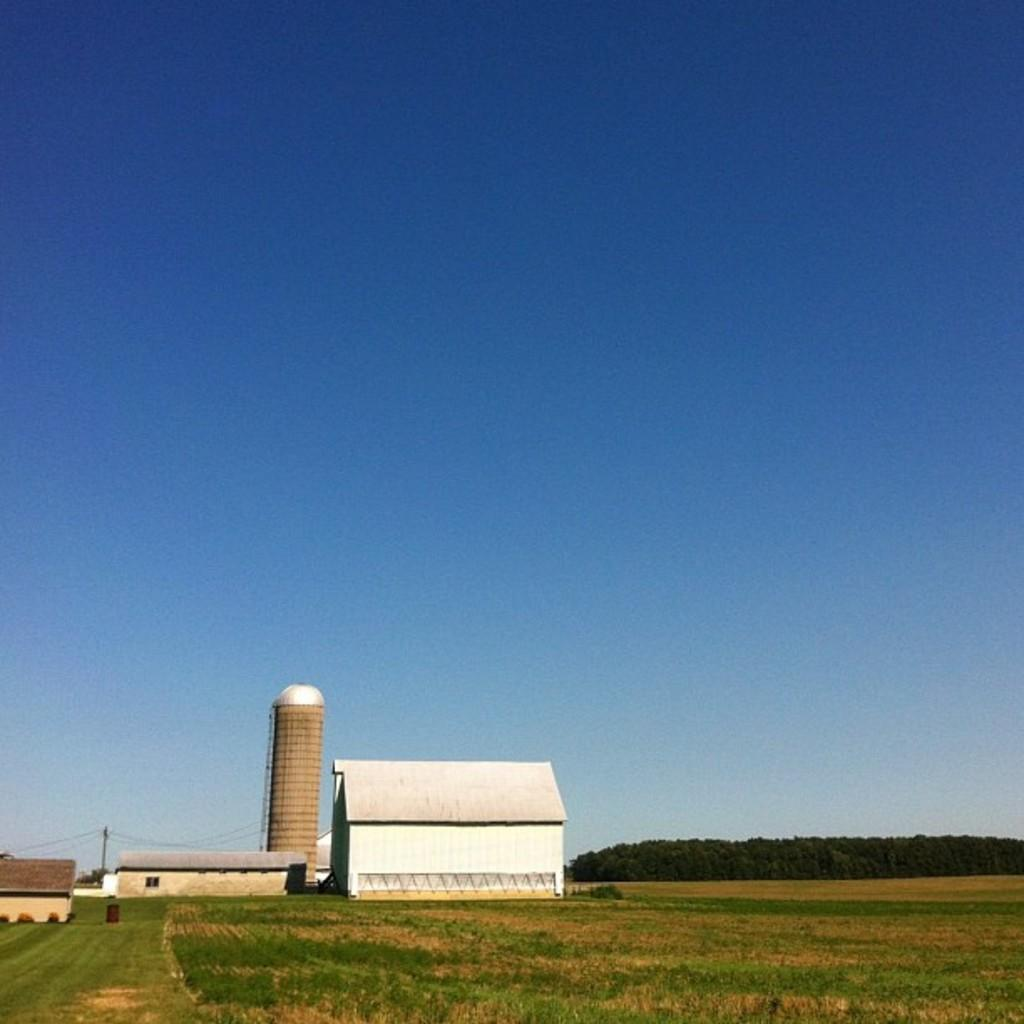What type of structures are visible in the image? There are houses and a tower in the image. What other natural elements can be seen in the image? There are trees and grass on the ground in the image. What is the color of the sky in the image? The sky is blue in the image. What type of reaction can be seen from the tower in the image? There is no reaction from the tower in the image, as it is an inanimate object. Was there an earthquake that caused the tower to lean in the image? There is no indication of an earthquake or any damage to the tower in the image. 